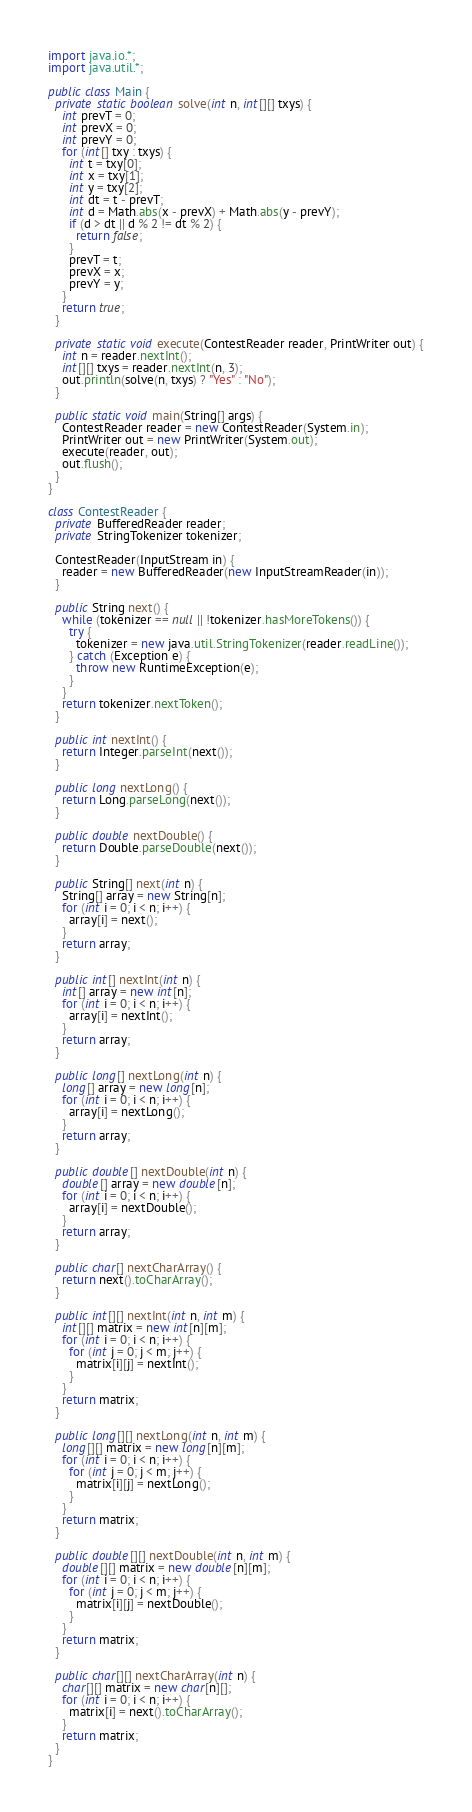<code> <loc_0><loc_0><loc_500><loc_500><_Java_>import java.io.*;
import java.util.*;

public class Main {
  private static boolean solve(int n, int[][] txys) {
    int prevT = 0;
    int prevX = 0;
    int prevY = 0;
    for (int[] txy : txys) {
      int t = txy[0];
      int x = txy[1];
      int y = txy[2];
      int dt = t - prevT;
      int d = Math.abs(x - prevX) + Math.abs(y - prevY);
      if (d > dt || d % 2 != dt % 2) {
        return false;
      }
      prevT = t;
      prevX = x;
      prevY = y;
    }
    return true;
  }
  
  private static void execute(ContestReader reader, PrintWriter out) {
    int n = reader.nextInt();
    int[][] txys = reader.nextInt(n, 3);
    out.println(solve(n, txys) ? "Yes" : "No");
  }
  
  public static void main(String[] args) {
    ContestReader reader = new ContestReader(System.in);
    PrintWriter out = new PrintWriter(System.out);
    execute(reader, out);
    out.flush();
  }
}

class ContestReader {
  private BufferedReader reader;
  private StringTokenizer tokenizer;
  
  ContestReader(InputStream in) {
    reader = new BufferedReader(new InputStreamReader(in));
  }
  
  public String next() {
    while (tokenizer == null || !tokenizer.hasMoreTokens()) {
      try {
        tokenizer = new java.util.StringTokenizer(reader.readLine());
      } catch (Exception e) {
        throw new RuntimeException(e);
      }
    }
    return tokenizer.nextToken();
  }
  
  public int nextInt() {
    return Integer.parseInt(next());
  }
  
  public long nextLong() {
    return Long.parseLong(next());
  }
  
  public double nextDouble() {
    return Double.parseDouble(next());
  }
  
  public String[] next(int n) {
    String[] array = new String[n];
    for (int i = 0; i < n; i++) {
      array[i] = next();
    }
    return array;
  }
  
  public int[] nextInt(int n) {
    int[] array = new int[n];
    for (int i = 0; i < n; i++) {
      array[i] = nextInt();
    }
    return array;
  }
  
  public long[] nextLong(int n) {
    long[] array = new long[n];
    for (int i = 0; i < n; i++) {
      array[i] = nextLong();
    }
    return array;
  }
  
  public double[] nextDouble(int n) {
    double[] array = new double[n];
    for (int i = 0; i < n; i++) {
      array[i] = nextDouble();
    }
    return array;
  }
  
  public char[] nextCharArray() {
    return next().toCharArray();
  }
  
  public int[][] nextInt(int n, int m) {
    int[][] matrix = new int[n][m];
    for (int i = 0; i < n; i++) {
      for (int j = 0; j < m; j++) {
        matrix[i][j] = nextInt();
      }
    }
    return matrix;
  }
  
  public long[][] nextLong(int n, int m) {
    long[][] matrix = new long[n][m];
    for (int i = 0; i < n; i++) {
      for (int j = 0; j < m; j++) {
        matrix[i][j] = nextLong();
      }
    }
    return matrix;
  }
  
  public double[][] nextDouble(int n, int m) {
    double[][] matrix = new double[n][m];
    for (int i = 0; i < n; i++) {
      for (int j = 0; j < m; j++) {
        matrix[i][j] = nextDouble();
      }
    }
    return matrix;
  }
  
  public char[][] nextCharArray(int n) {
    char[][] matrix = new char[n][];
    for (int i = 0; i < n; i++) {
      matrix[i] = next().toCharArray();
    }
    return matrix;
  }
}
</code> 